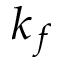<formula> <loc_0><loc_0><loc_500><loc_500>k _ { f }</formula> 